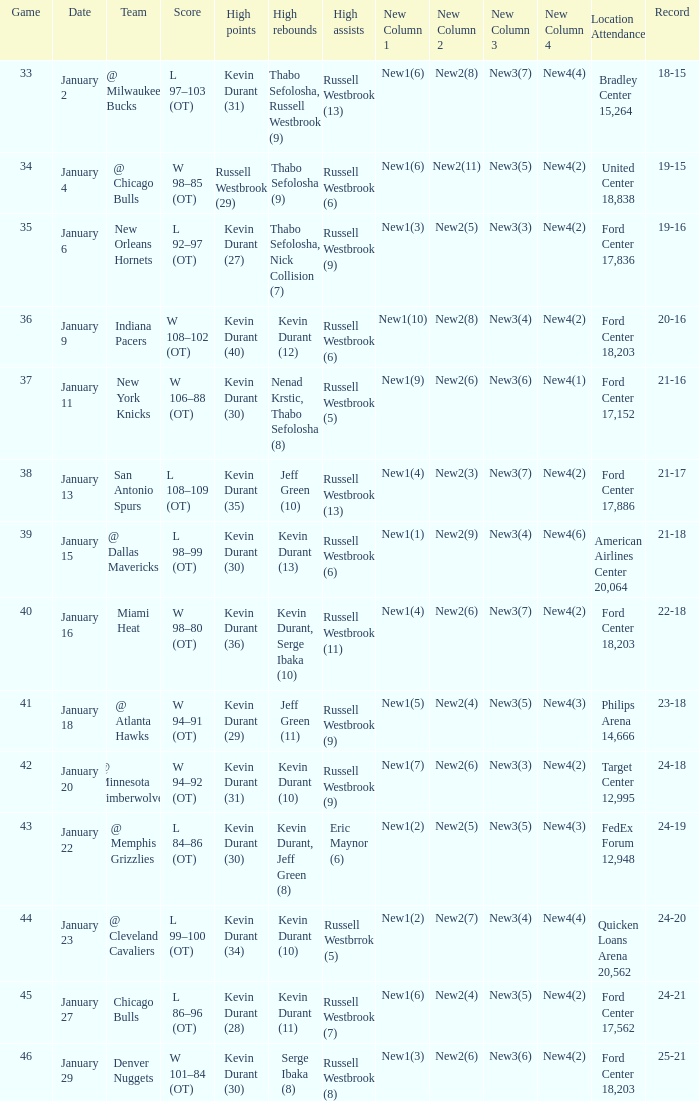Name the least game for january 29 46.0. 